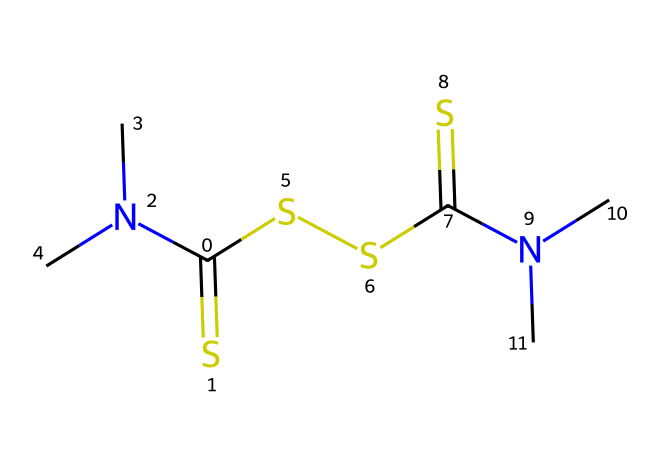What is the total number of sulfur atoms in thiram? By examining the SMILES representation, we see there are two "S" symbols indicating two sulfur atoms present in the structure.
Answer: 2 What is the main functional group present in thiram? The presence of the "N(C)" in the SMILES shows that there are nitrogen atoms, which together with the carbon atoms form amine groups that are characteristic of thiram's structure.
Answer: amine How many carbon atoms are present in thiram? Counting the "C" symbols in the SMILES representation, we find there are four carbon atoms indicated in the structure.
Answer: 4 Is thiram a systemic or contact fungicide? Thiram is known to be a contact fungicide used primarily for protection, so it acts on contact rather than being absorbed systemically.
Answer: contact What is the role of thiram in cricket ball leather treatments? In cricket ball leather treatments, thiram is used to prevent fungal growth which enhances the durability and quality of the leather.
Answer: antifungal How many nitrogen atoms are present in thiram? The SMILES indicates there are two "N" symbols, which means thiram contains two nitrogen atoms in its structure.
Answer: 2 What type of bonding is primarily involved in the thiram structure? The presence of multiple "N" and "S" atoms suggests there is significant covalent bonding occurring in thiram's structure.
Answer: covalent 